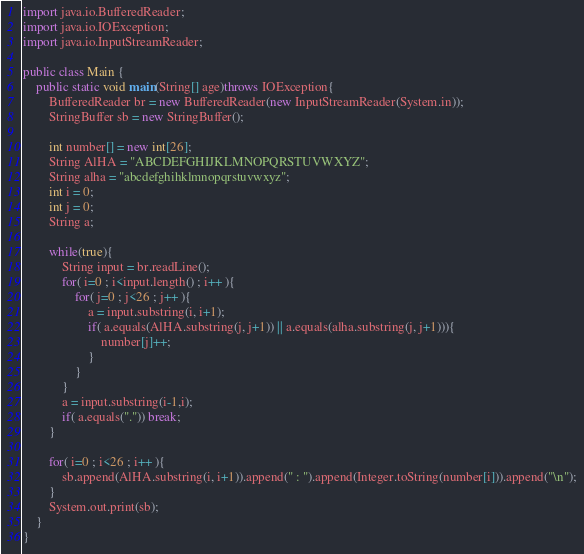<code> <loc_0><loc_0><loc_500><loc_500><_Java_>import java.io.BufferedReader;
import java.io.IOException;
import java.io.InputStreamReader;

public class Main {
	public static void main(String[] age)throws IOException{
		BufferedReader br = new BufferedReader(new InputStreamReader(System.in));
		StringBuffer sb = new StringBuffer();

		int number[] = new int[26];
		String AlHA = "ABCDEFGHIJKLMNOPQRSTUVWXYZ";
		String alha = "abcdefghihklmnopqrstuvwxyz";
		int i = 0;
		int j = 0;
		String a;

		while(true){
			String input = br.readLine();
			for( i=0 ; i<input.length() ; i++ ){
				for( j=0 ; j<26 ; j++ ){
					a = input.substring(i, i+1);
					if( a.equals(AlHA.substring(j, j+1)) || a.equals(alha.substring(j, j+1))){
						number[j]++;
					}
				}
			}
			a = input.substring(i-1,i);
			if( a.equals(".")) break;
		}

		for( i=0 ; i<26 ; i++ ){
			sb.append(AlHA.substring(i, i+1)).append(" : ").append(Integer.toString(number[i])).append("\n");
		}
		System.out.print(sb);
	}
}</code> 